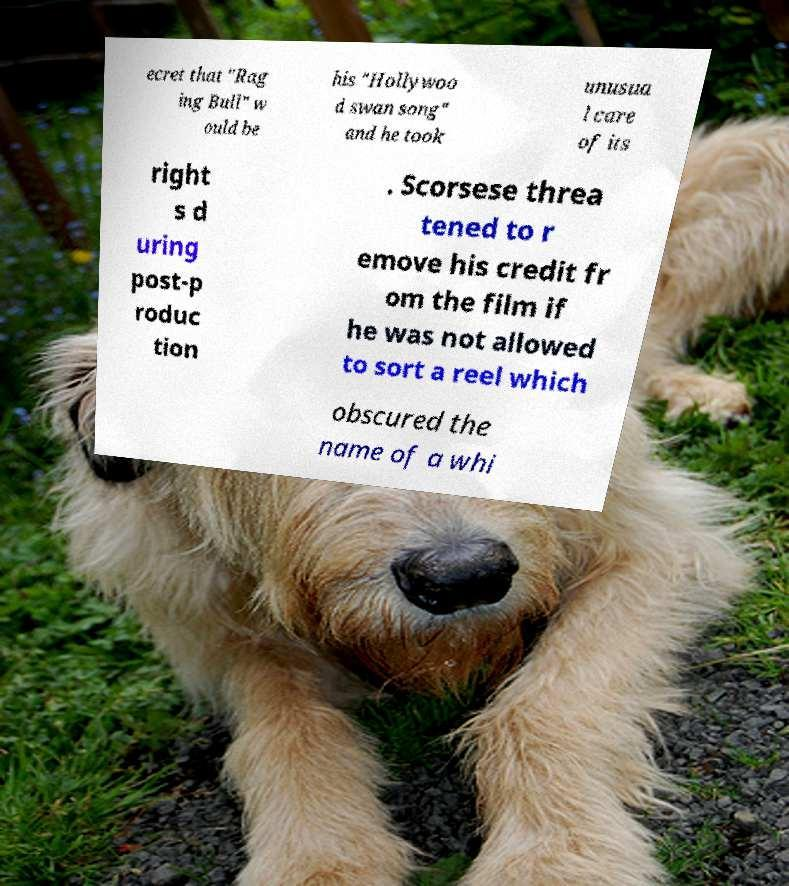Could you assist in decoding the text presented in this image and type it out clearly? ecret that "Rag ing Bull" w ould be his "Hollywoo d swan song" and he took unusua l care of its right s d uring post-p roduc tion . Scorsese threa tened to r emove his credit fr om the film if he was not allowed to sort a reel which obscured the name of a whi 